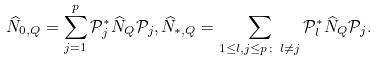<formula> <loc_0><loc_0><loc_500><loc_500>\widehat { N } _ { 0 , Q } = \sum _ { j = 1 } ^ { p } \mathcal { P } _ { j } ^ { * } \widehat { N } _ { Q } \mathcal { P } _ { j } , \widehat { N } _ { * , Q } = \sum _ { 1 \leq l , j \leq p \colon \, l \ne j } \mathcal { P } _ { l } ^ { * } \widehat { N } _ { Q } \mathcal { P } _ { j } .</formula> 